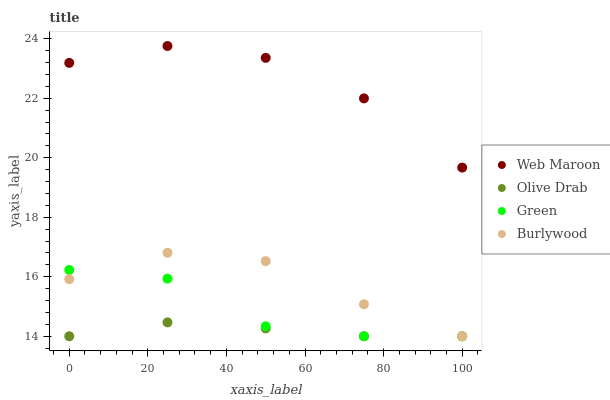Does Olive Drab have the minimum area under the curve?
Answer yes or no. Yes. Does Web Maroon have the maximum area under the curve?
Answer yes or no. Yes. Does Green have the minimum area under the curve?
Answer yes or no. No. Does Green have the maximum area under the curve?
Answer yes or no. No. Is Olive Drab the smoothest?
Answer yes or no. Yes. Is Green the roughest?
Answer yes or no. Yes. Is Web Maroon the smoothest?
Answer yes or no. No. Is Web Maroon the roughest?
Answer yes or no. No. Does Burlywood have the lowest value?
Answer yes or no. Yes. Does Web Maroon have the lowest value?
Answer yes or no. No. Does Web Maroon have the highest value?
Answer yes or no. Yes. Does Green have the highest value?
Answer yes or no. No. Is Olive Drab less than Web Maroon?
Answer yes or no. Yes. Is Web Maroon greater than Green?
Answer yes or no. Yes. Does Burlywood intersect Olive Drab?
Answer yes or no. Yes. Is Burlywood less than Olive Drab?
Answer yes or no. No. Is Burlywood greater than Olive Drab?
Answer yes or no. No. Does Olive Drab intersect Web Maroon?
Answer yes or no. No. 